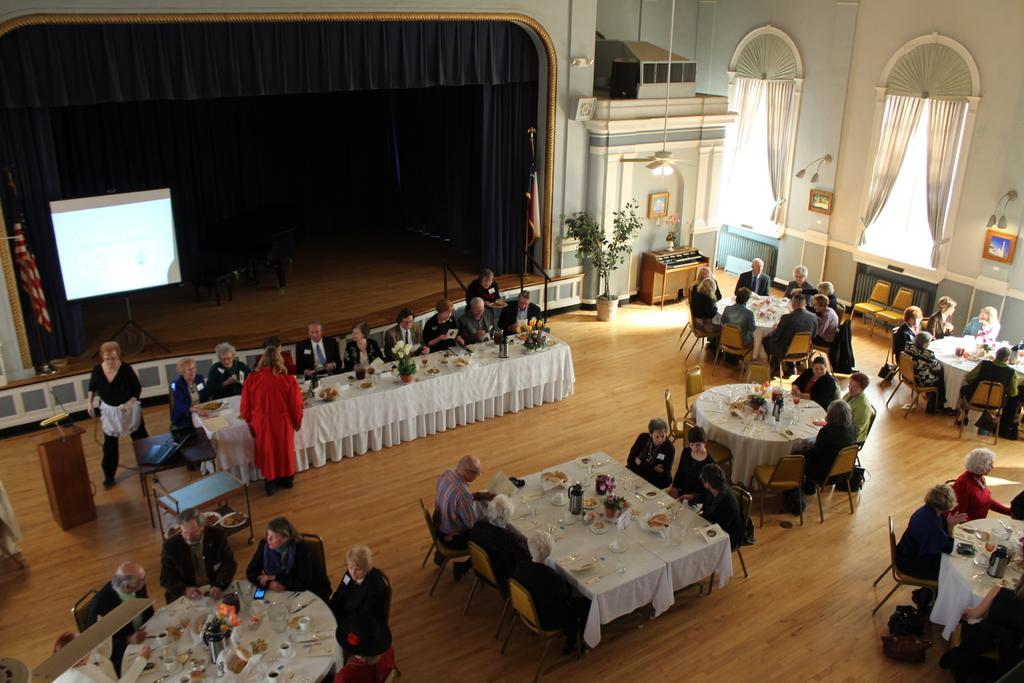Please provide a concise description of this image. In this picture we can see a group of people sitting on chairs and in front of them on table we have jar, flowers, plates, mobile, knife, spoons, cup and aside to this table we have podium mic on it and in the background we can see curtains, screen, wall, pillars, frames, flower pot with plant in it. 